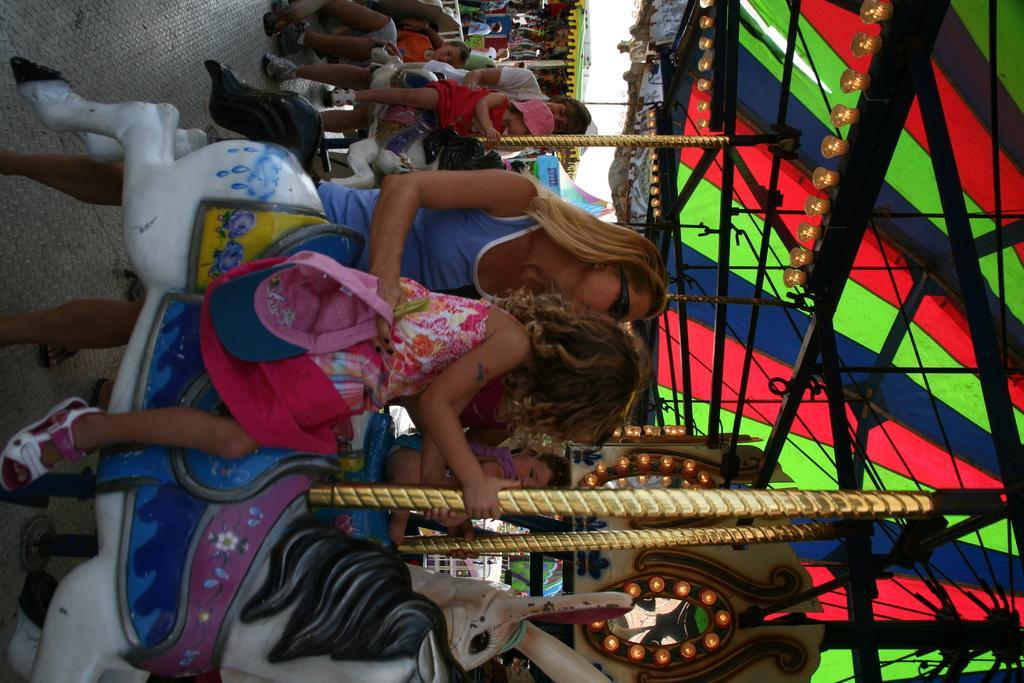Describe this image in one or two sentences. Here people are sitting on the horse. 